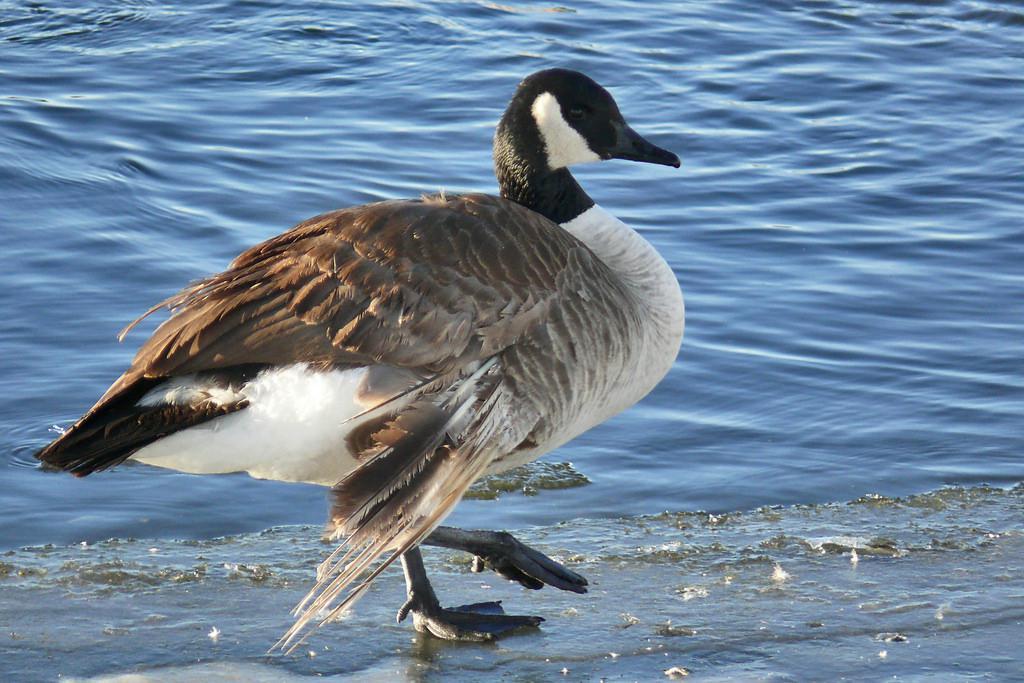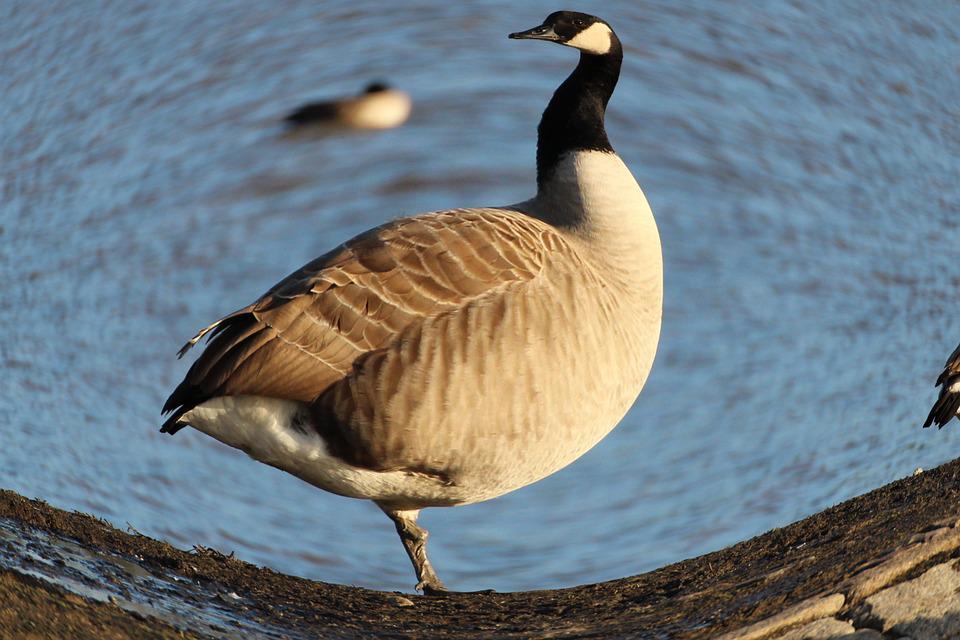The first image is the image on the left, the second image is the image on the right. Analyze the images presented: Is the assertion "One image shows an adult Canada goose and at least one gosling, while the other image shows all adult Canada geese." valid? Answer yes or no. No. The first image is the image on the left, the second image is the image on the right. Analyze the images presented: Is the assertion "An image shows at least one baby gosling next to an adult goose." valid? Answer yes or no. No. 